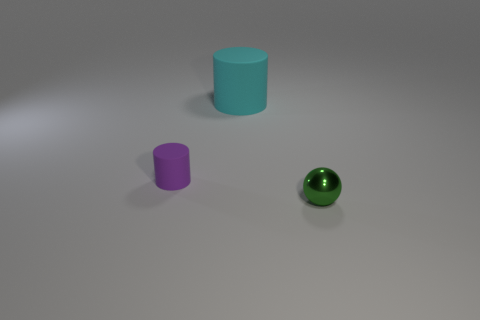What number of other matte cylinders have the same color as the tiny cylinder?
Your answer should be compact. 0. The tiny matte object that is the same shape as the large rubber thing is what color?
Your answer should be compact. Purple. The object that is right of the small matte cylinder and in front of the big rubber object is made of what material?
Offer a terse response. Metal. Do the small thing that is to the right of the large matte thing and the object that is left of the big cylinder have the same material?
Your answer should be very brief. No. What size is the green sphere?
Keep it short and to the point. Small. What size is the purple object that is the same shape as the cyan rubber object?
Make the answer very short. Small. What number of tiny purple matte objects are to the right of the metallic ball?
Your answer should be compact. 0. What is the color of the thing that is in front of the tiny thing that is to the left of the big rubber thing?
Ensure brevity in your answer.  Green. Is there anything else that has the same shape as the small purple thing?
Your response must be concise. Yes. Are there an equal number of tiny purple things that are left of the small purple rubber cylinder and tiny matte things to the right of the small green object?
Offer a very short reply. Yes. 